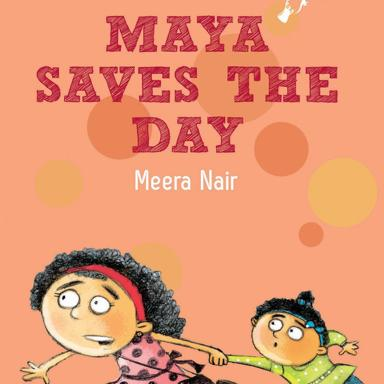What is the title and author of the children's book mentioned in the image? The title of the book is "Meyh Saves The Day" and it is written by Meera Nair. Can you describe the visual content of the image? The image shows a cartoon of two girls running with a balloon. 